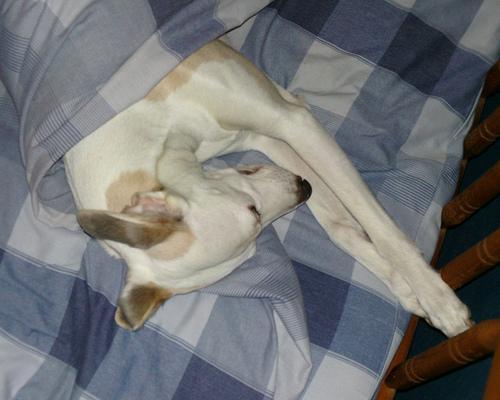How many dogs are photographed?
Give a very brief answer. 1. 